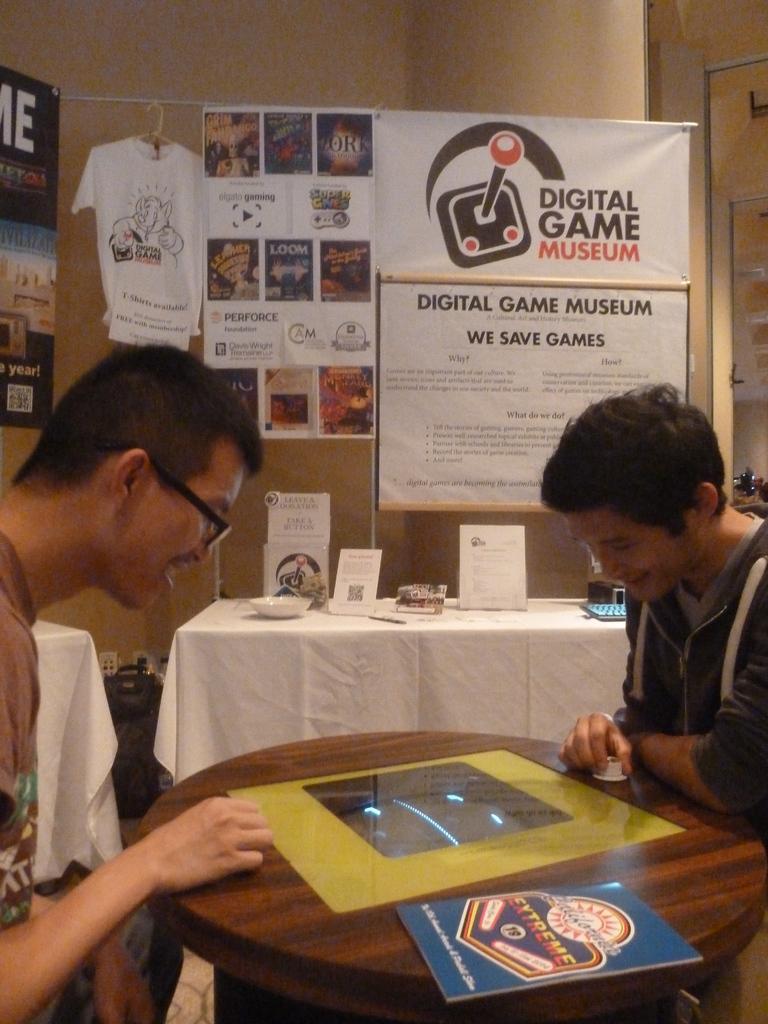How would you summarize this image in a sentence or two? In the middle there is a table on that there is a book. On right there is a man he is staring at the table. On the left there is a man he is smiling. In the background there is a table,bowl,poster,t shirt and wall. 